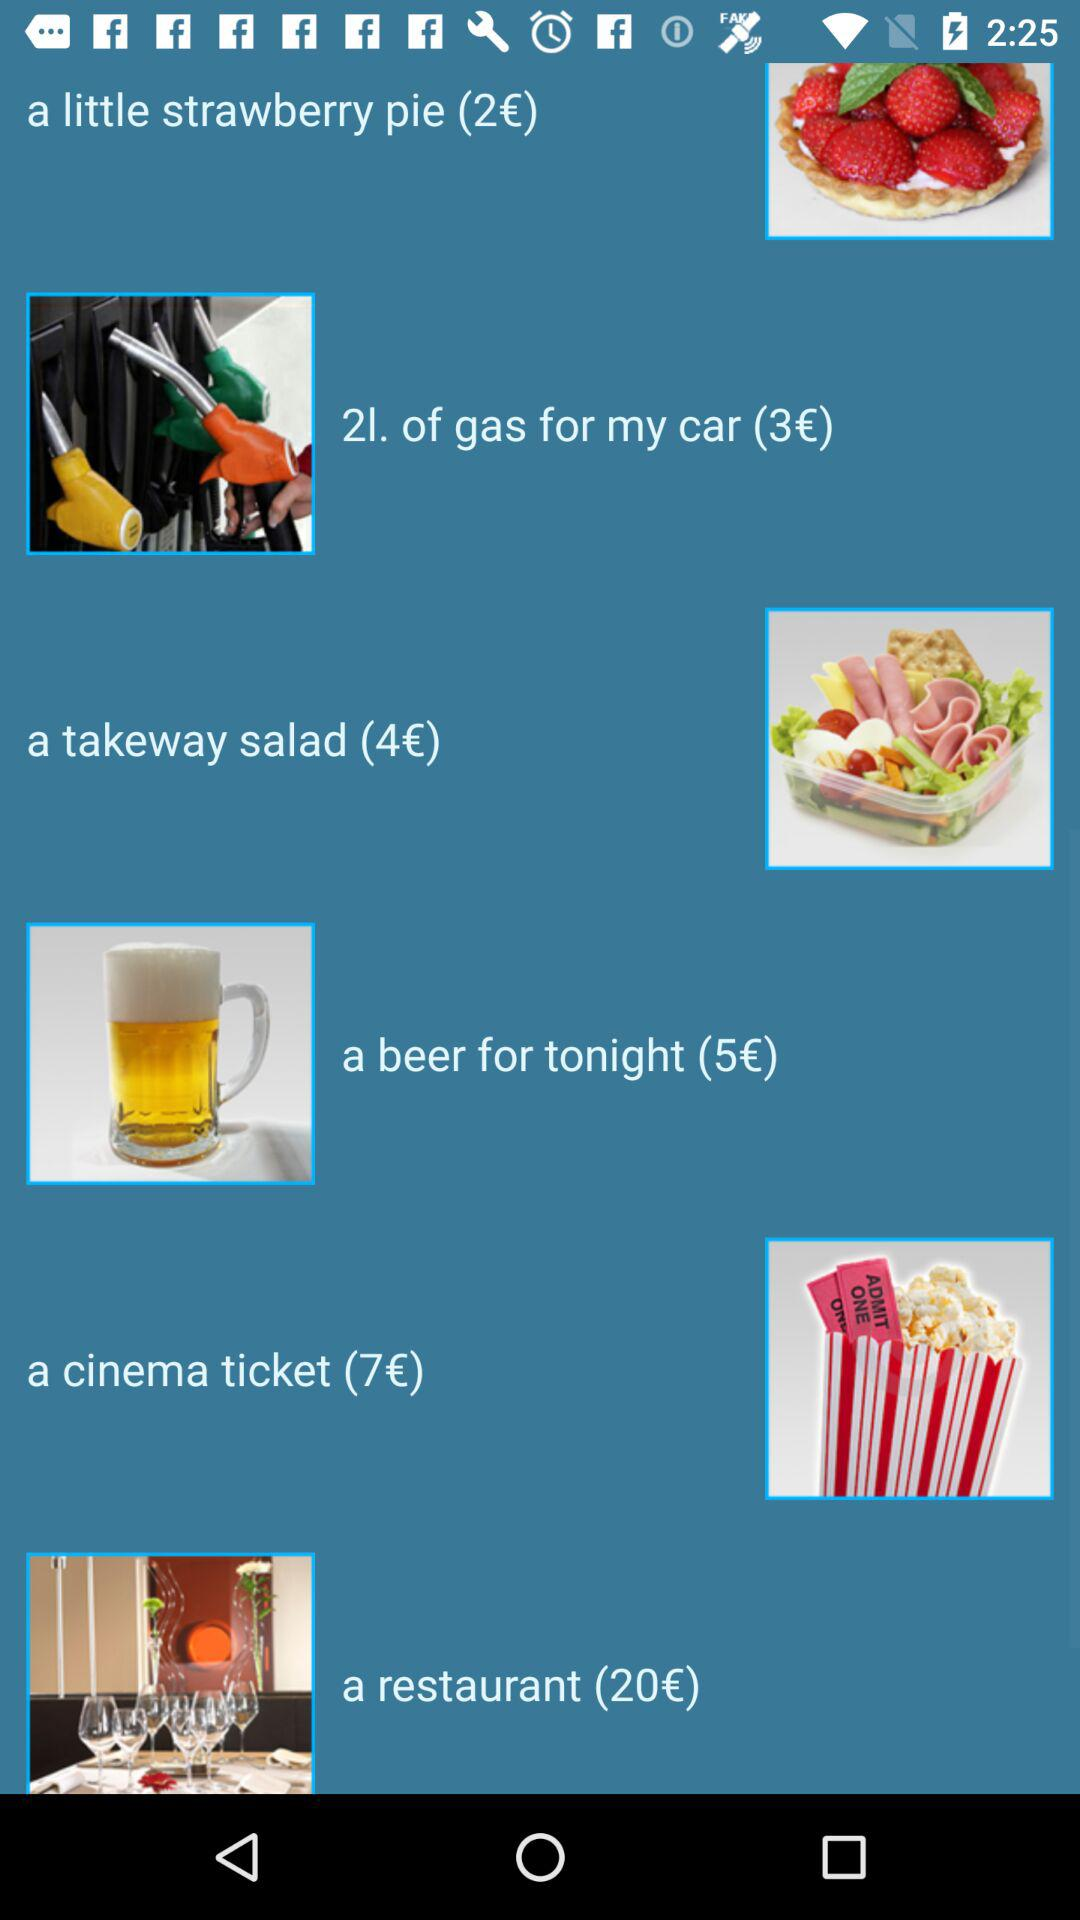How much does "a takeway salad" cost in rupees?
When the provided information is insufficient, respond with <no answer>. <no answer> 